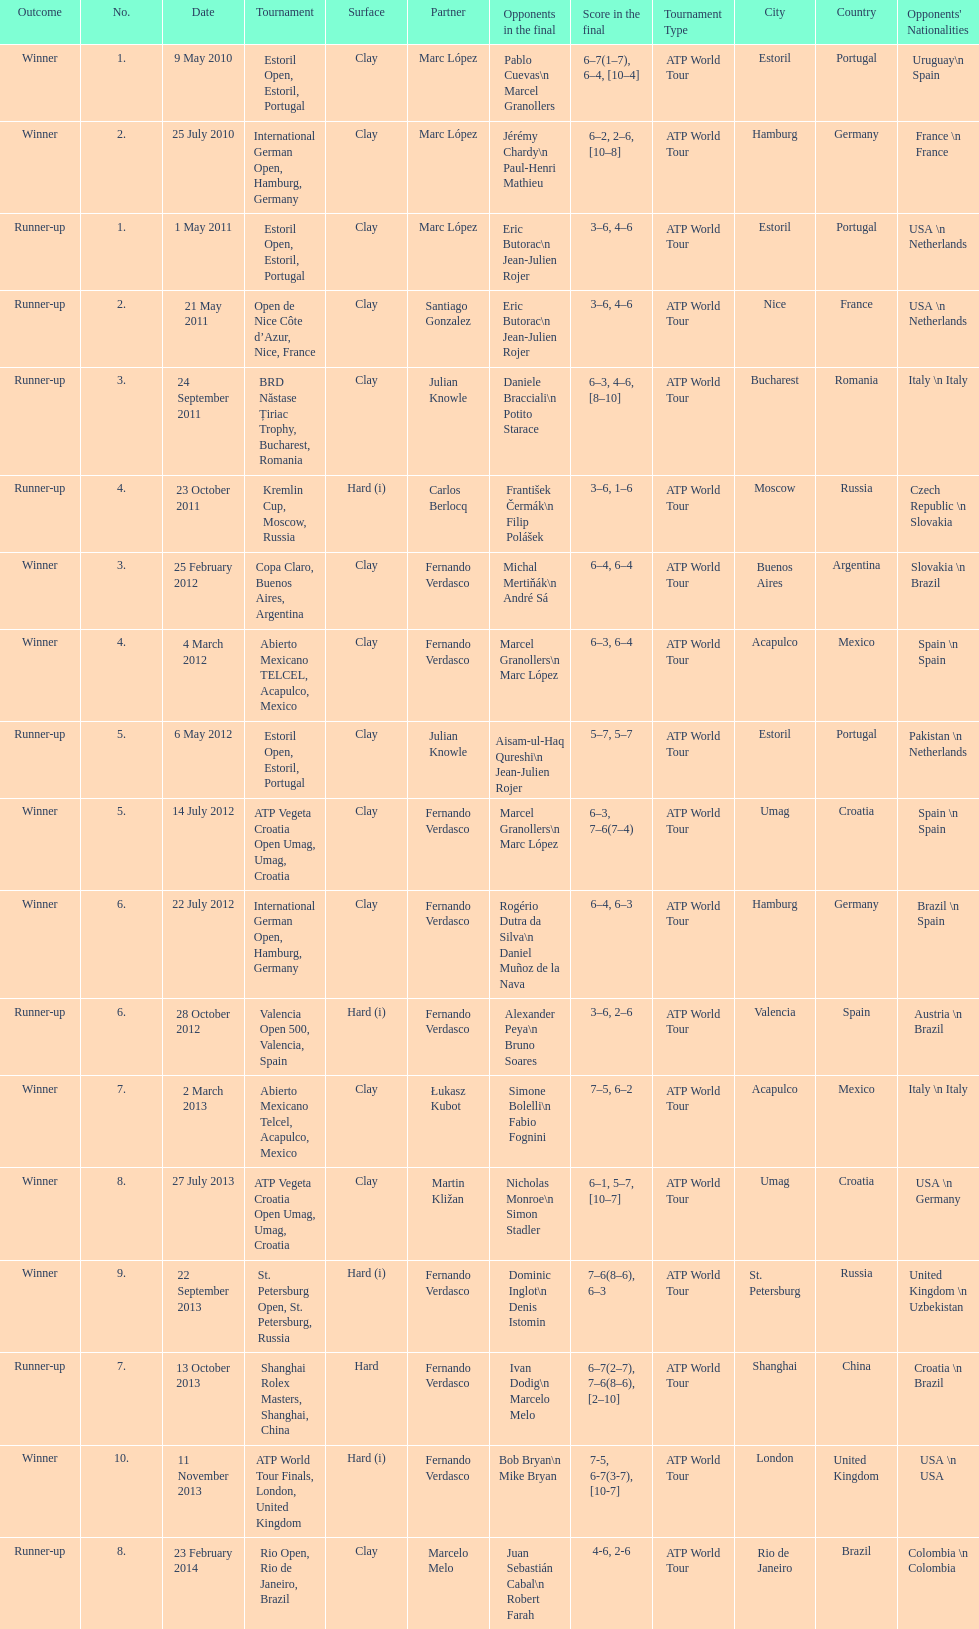How many winners are there? 10. 